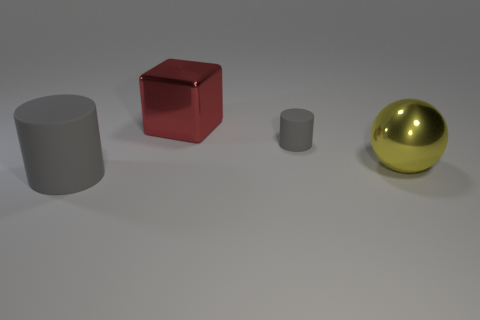What color is the rubber cylinder that is to the right of the rubber object that is on the left side of the metallic cube?
Offer a terse response. Gray. Does the yellow thing have the same size as the red metal block?
Your answer should be very brief. Yes. How many cubes are gray things or metallic things?
Your response must be concise. 1. What number of matte objects are to the left of the cylinder on the left side of the tiny matte cylinder?
Ensure brevity in your answer.  0. Is the shape of the large red thing the same as the tiny gray rubber thing?
Offer a terse response. No. The other gray rubber object that is the same shape as the small object is what size?
Your answer should be compact. Large. What shape is the matte thing that is right of the gray rubber cylinder left of the red metallic object?
Provide a short and direct response. Cylinder. The cube is what size?
Keep it short and to the point. Large. There is a red object; what shape is it?
Offer a very short reply. Cube. There is a small rubber thing; is it the same shape as the large metallic thing behind the tiny gray cylinder?
Keep it short and to the point. No. 